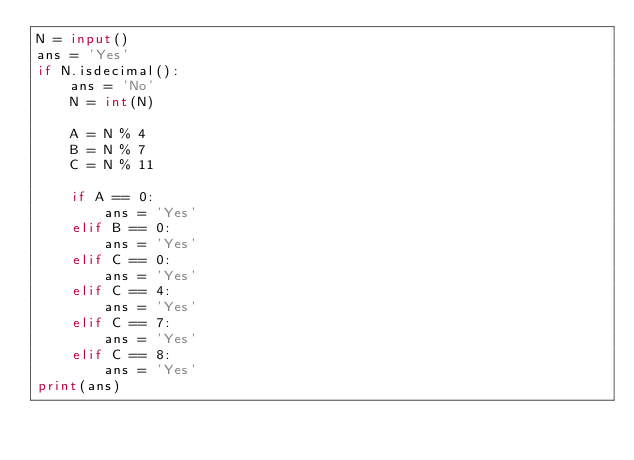<code> <loc_0><loc_0><loc_500><loc_500><_Python_>N = input()
ans = 'Yes'
if N.isdecimal():
    ans = 'No'
    N = int(N)

    A = N % 4
    B = N % 7
    C = N % 11

    if A == 0:
        ans = 'Yes'
    elif B == 0:
        ans = 'Yes'
    elif C == 0:
        ans = 'Yes'
    elif C == 4:
        ans = 'Yes'
    elif C == 7:
        ans = 'Yes'
    elif C == 8:
        ans = 'Yes'
print(ans)</code> 